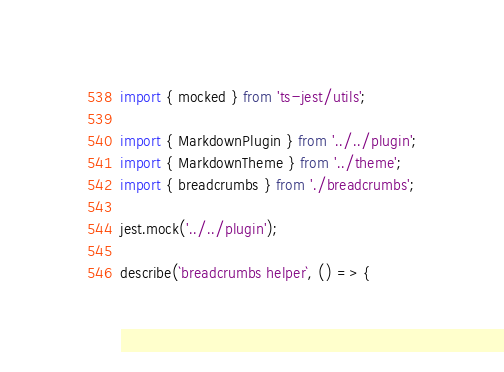Convert code to text. <code><loc_0><loc_0><loc_500><loc_500><_TypeScript_>import { mocked } from 'ts-jest/utils';

import { MarkdownPlugin } from '../../plugin';
import { MarkdownTheme } from '../theme';
import { breadcrumbs } from './breadcrumbs';

jest.mock('../../plugin');

describe(`breadcrumbs helper`, () => {</code> 